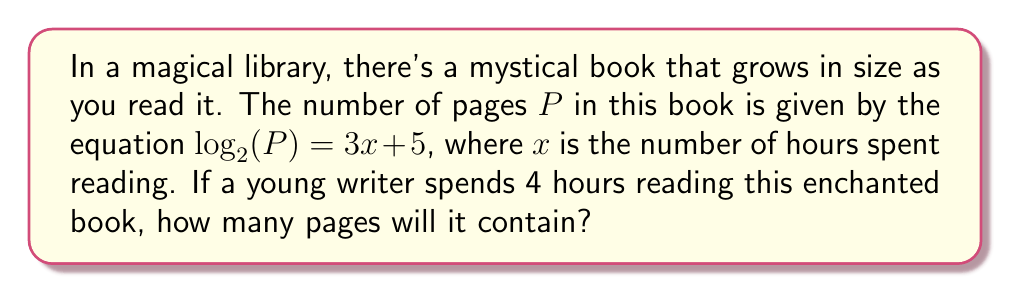Give your solution to this math problem. Let's solve this step-by-step:

1) We are given the equation: $\log_2(P) = 3x + 5$

2) We know that $x = 4$ (hours spent reading)

3) Let's substitute $x = 4$ into the equation:
   $\log_2(P) = 3(4) + 5$
   $\log_2(P) = 12 + 5$
   $\log_2(P) = 17$

4) Now we need to solve for $P$. We can do this by applying the inverse function (exponential) to both sides:
   $2^{\log_2(P)} = 2^{17}$

5) The left side simplifies to $P$ because $2^{\log_2(P)} = P$:
   $P = 2^{17}$

6) Calculate $2^{17}$:
   $P = 131,072$

Therefore, after 4 hours of reading, the magical book will contain 131,072 pages.
Answer: 131,072 pages 